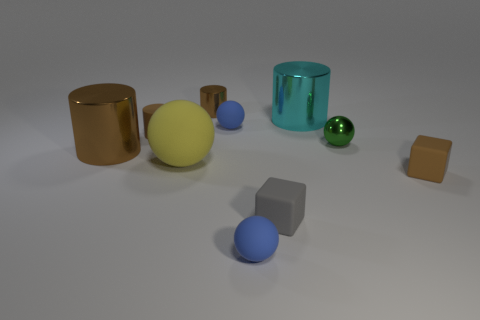Subtract all cyan spheres. How many brown cylinders are left? 3 Subtract all cylinders. How many objects are left? 6 Add 9 cyan metal things. How many cyan metal things are left? 10 Add 7 brown rubber cubes. How many brown rubber cubes exist? 8 Subtract 1 green balls. How many objects are left? 9 Subtract all tiny gray matte cubes. Subtract all large yellow objects. How many objects are left? 8 